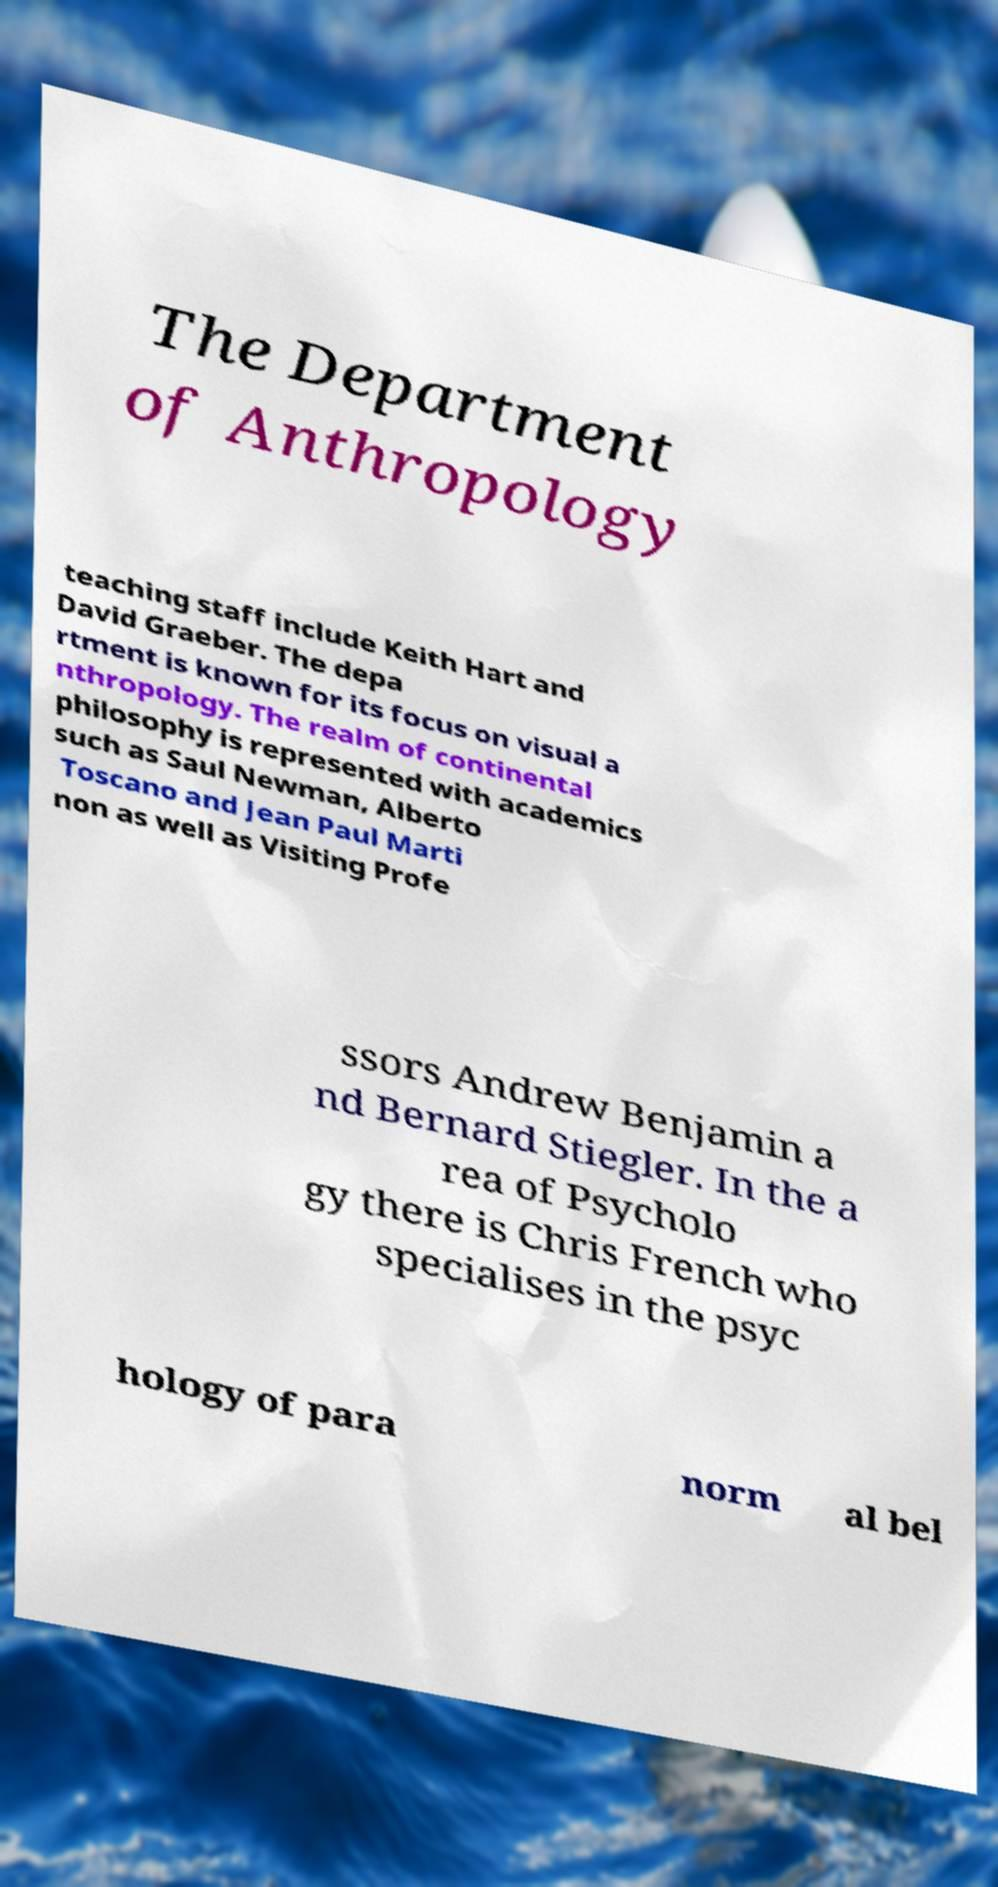Please read and relay the text visible in this image. What does it say? The Department of Anthropology teaching staff include Keith Hart and David Graeber. The depa rtment is known for its focus on visual a nthropology. The realm of continental philosophy is represented with academics such as Saul Newman, Alberto Toscano and Jean Paul Marti non as well as Visiting Profe ssors Andrew Benjamin a nd Bernard Stiegler. In the a rea of Psycholo gy there is Chris French who specialises in the psyc hology of para norm al bel 